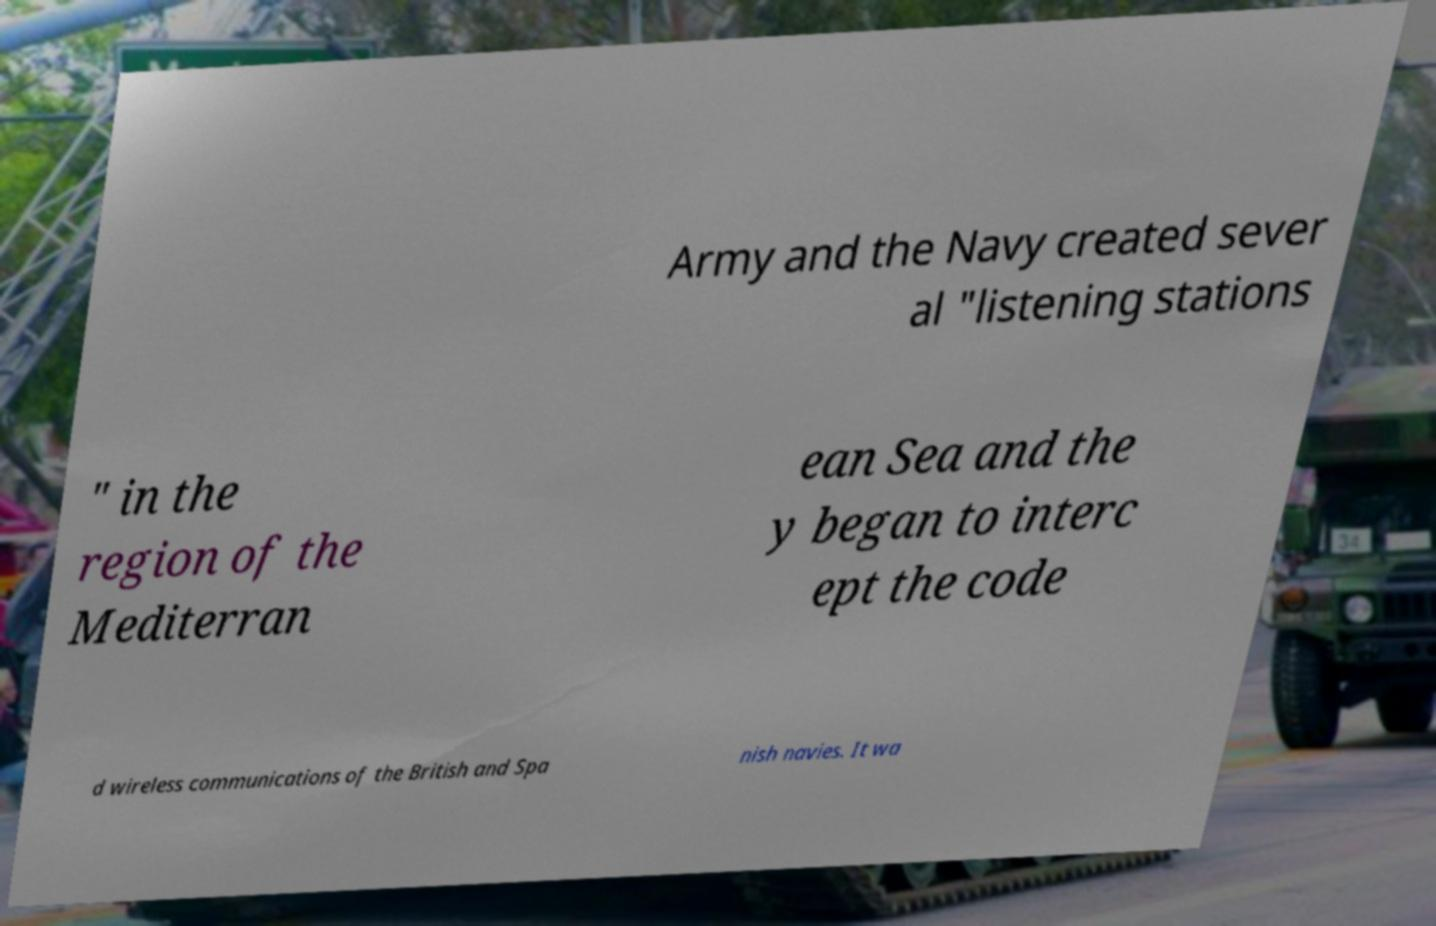There's text embedded in this image that I need extracted. Can you transcribe it verbatim? Army and the Navy created sever al "listening stations " in the region of the Mediterran ean Sea and the y began to interc ept the code d wireless communications of the British and Spa nish navies. It wa 